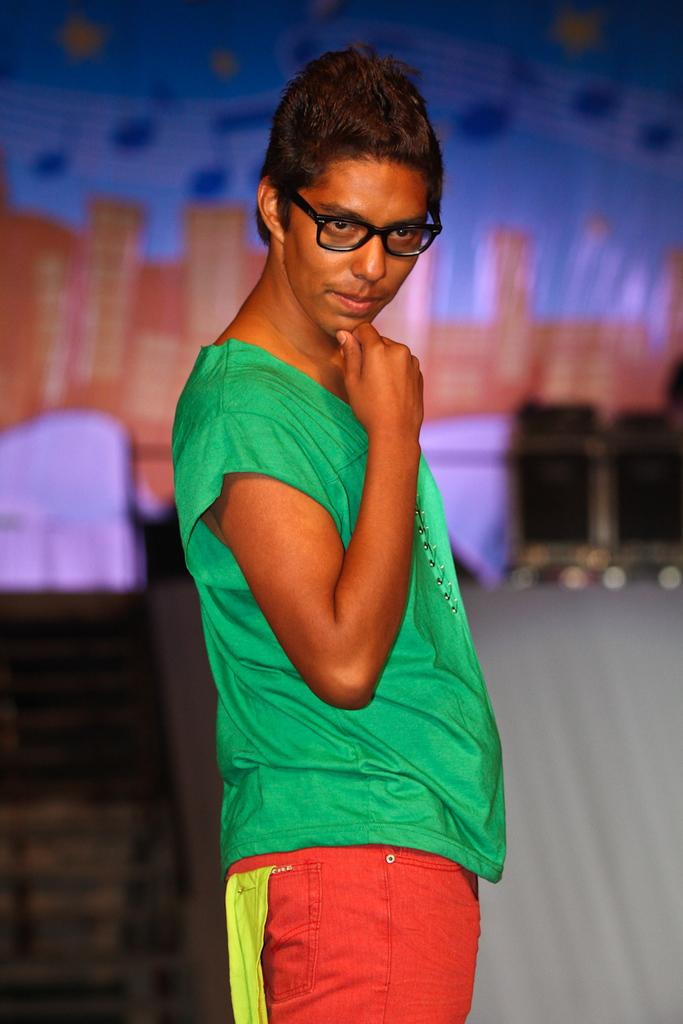What can be seen in the image? There is a person in the image. Can you describe the person's appearance? The person is wearing spectacles. What is the background of the image like? The background of the image is blurry. What type of cable can be seen hanging from the person's ear in the image? There is no cable hanging from the person's ear in the image. How many pears are visible on the person's head in the image? There are no pears visible on the person's head in the image. 